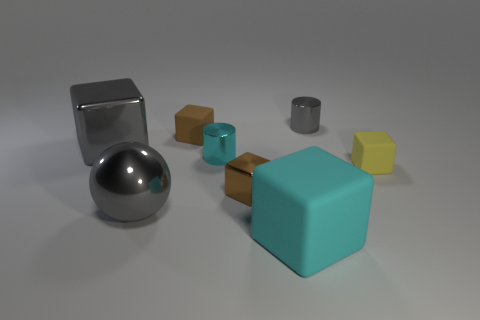There is a small brown object behind the big metallic block; is its shape the same as the small yellow matte object?
Provide a short and direct response. Yes. Is there any other thing that has the same size as the gray cylinder?
Offer a very short reply. Yes. Are there fewer small shiny cylinders in front of the shiny ball than large gray objects in front of the yellow object?
Your answer should be compact. Yes. What number of other things are there of the same shape as the brown metal thing?
Offer a very short reply. 4. What size is the block to the left of the small brown thing behind the small shiny cylinder on the left side of the large matte cube?
Your answer should be compact. Large. How many red objects are either tiny rubber things or tiny cubes?
Your answer should be compact. 0. The brown object that is in front of the large metal object behind the gray ball is what shape?
Your answer should be very brief. Cube. Is the size of the cyan metal cylinder in front of the gray metallic cylinder the same as the metallic cube on the left side of the tiny brown matte cube?
Offer a very short reply. No. Is there a gray thing made of the same material as the big cyan thing?
Provide a succinct answer. No. What size is the metal block that is the same color as the big shiny sphere?
Ensure brevity in your answer.  Large. 